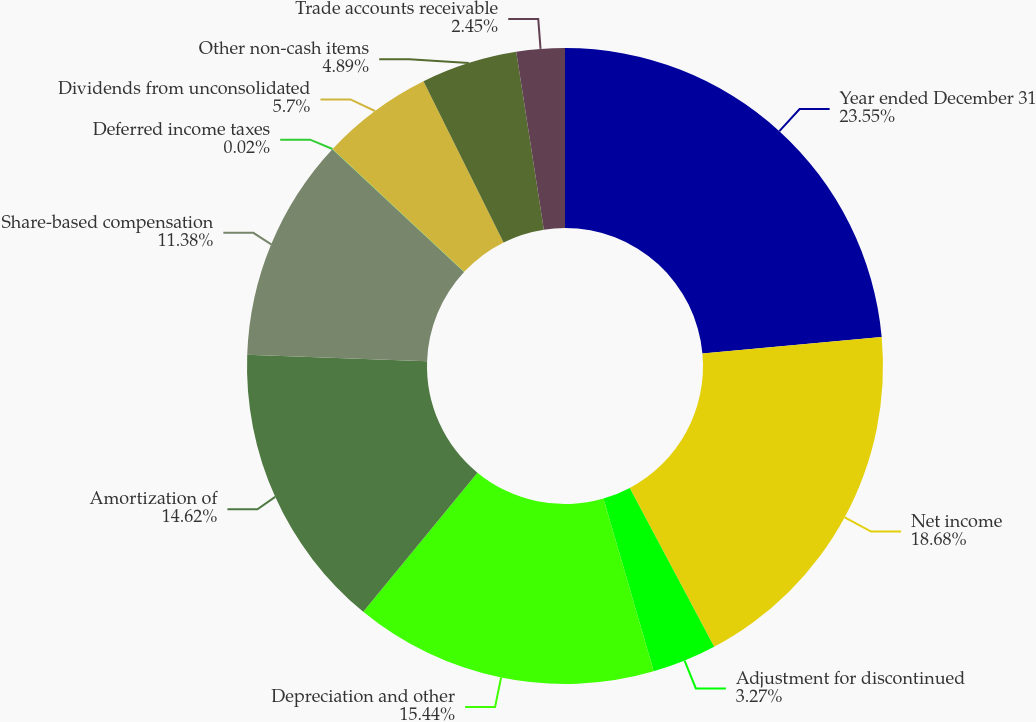Convert chart to OTSL. <chart><loc_0><loc_0><loc_500><loc_500><pie_chart><fcel>Year ended December 31<fcel>Net income<fcel>Adjustment for discontinued<fcel>Depreciation and other<fcel>Amortization of<fcel>Share-based compensation<fcel>Deferred income taxes<fcel>Dividends from unconsolidated<fcel>Other non-cash items<fcel>Trade accounts receivable<nl><fcel>23.55%<fcel>18.68%<fcel>3.27%<fcel>15.44%<fcel>14.62%<fcel>11.38%<fcel>0.02%<fcel>5.7%<fcel>4.89%<fcel>2.45%<nl></chart> 